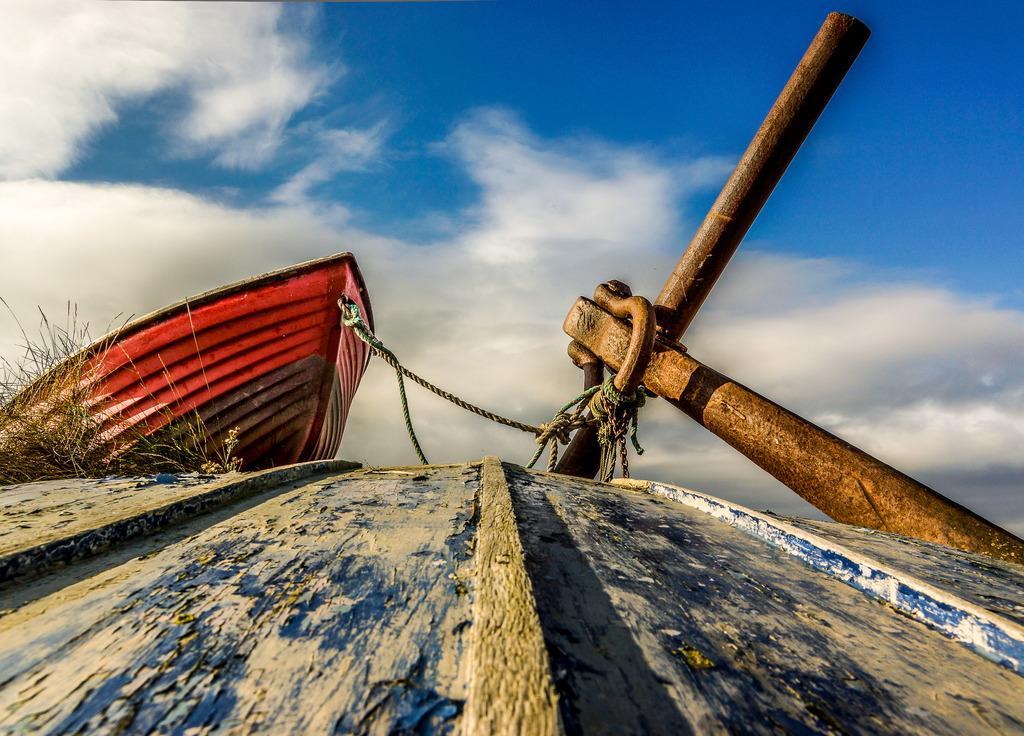Can you describe this image briefly? In this image there is wooden surface, in the background there are plants and a boat tied to an iron road and there is the sky. 